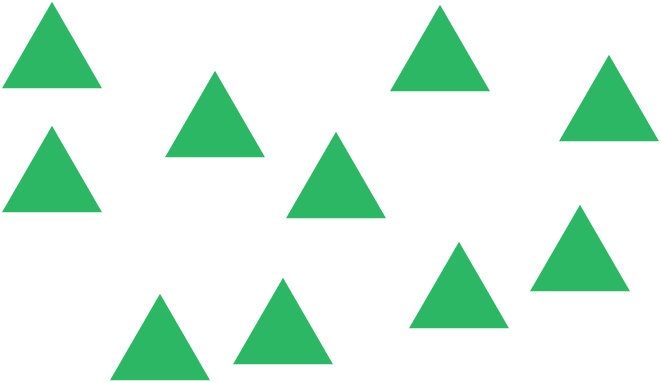What geometrical properties can you observe in these triangles? The triangles in the image all appear to be equilateral, meaning all sides of each triangle are of equal length. This symmetry gives them an aesthetically pleasing and balanced appearance. Observing these shapes can aid in understanding concepts of equality and symmetry in geometry. 